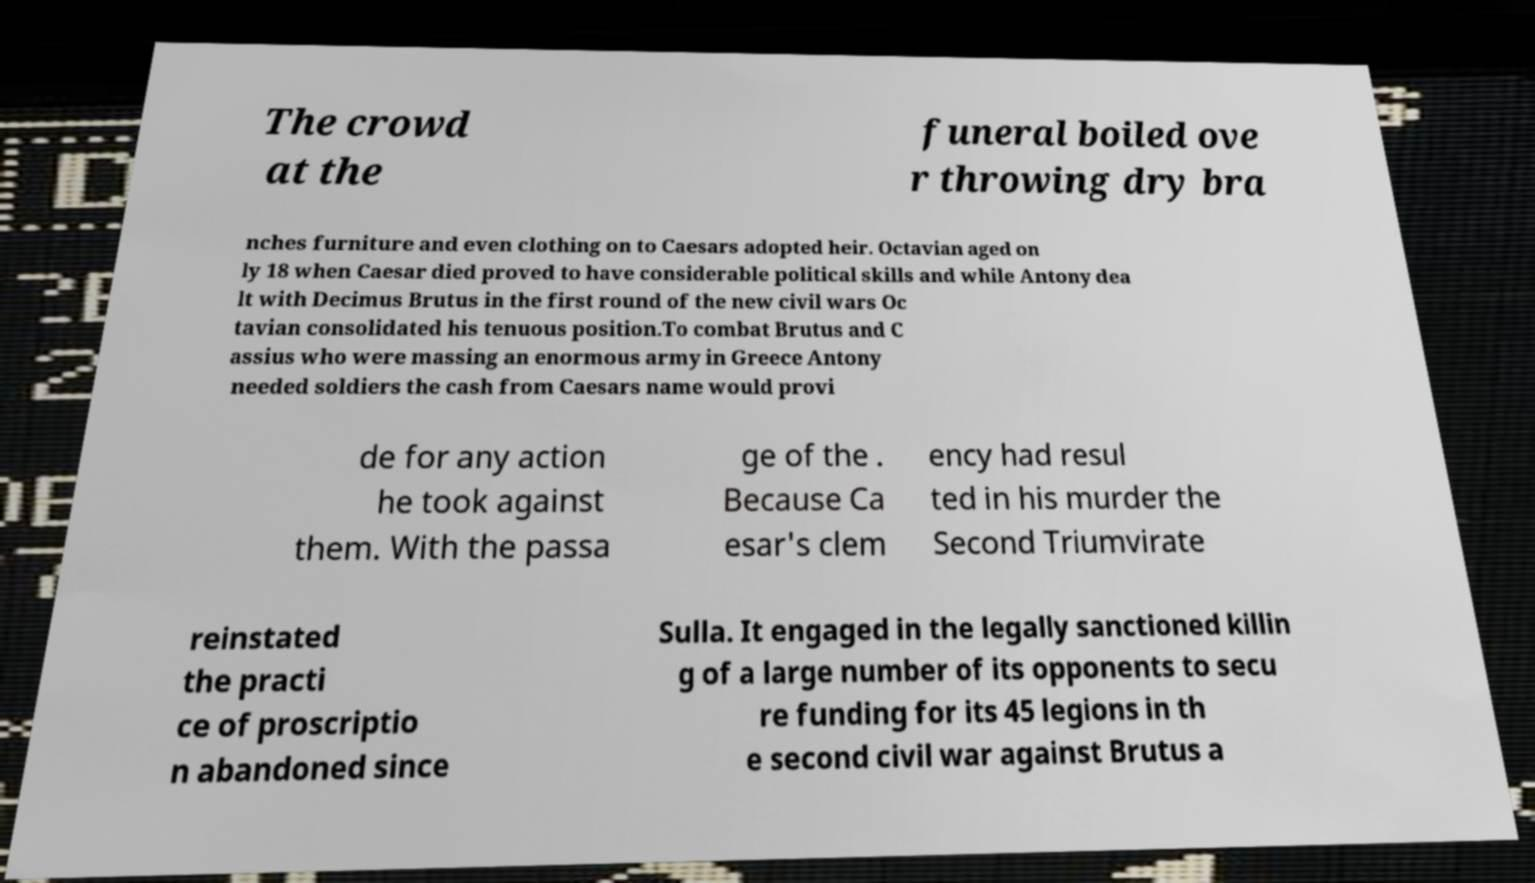There's text embedded in this image that I need extracted. Can you transcribe it verbatim? The crowd at the funeral boiled ove r throwing dry bra nches furniture and even clothing on to Caesars adopted heir. Octavian aged on ly 18 when Caesar died proved to have considerable political skills and while Antony dea lt with Decimus Brutus in the first round of the new civil wars Oc tavian consolidated his tenuous position.To combat Brutus and C assius who were massing an enormous army in Greece Antony needed soldiers the cash from Caesars name would provi de for any action he took against them. With the passa ge of the . Because Ca esar's clem ency had resul ted in his murder the Second Triumvirate reinstated the practi ce of proscriptio n abandoned since Sulla. It engaged in the legally sanctioned killin g of a large number of its opponents to secu re funding for its 45 legions in th e second civil war against Brutus a 